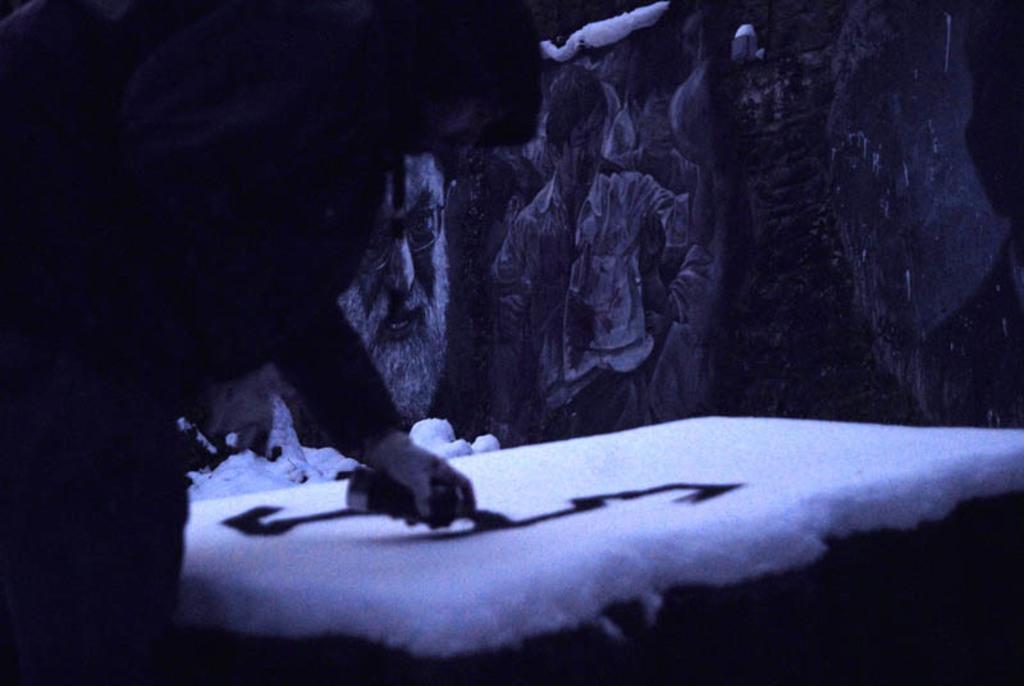Describe this image in one or two sentences. There is a person holdings an object, it seems like putting on the ice in the foreground area of the image, there are sketches in the background. 